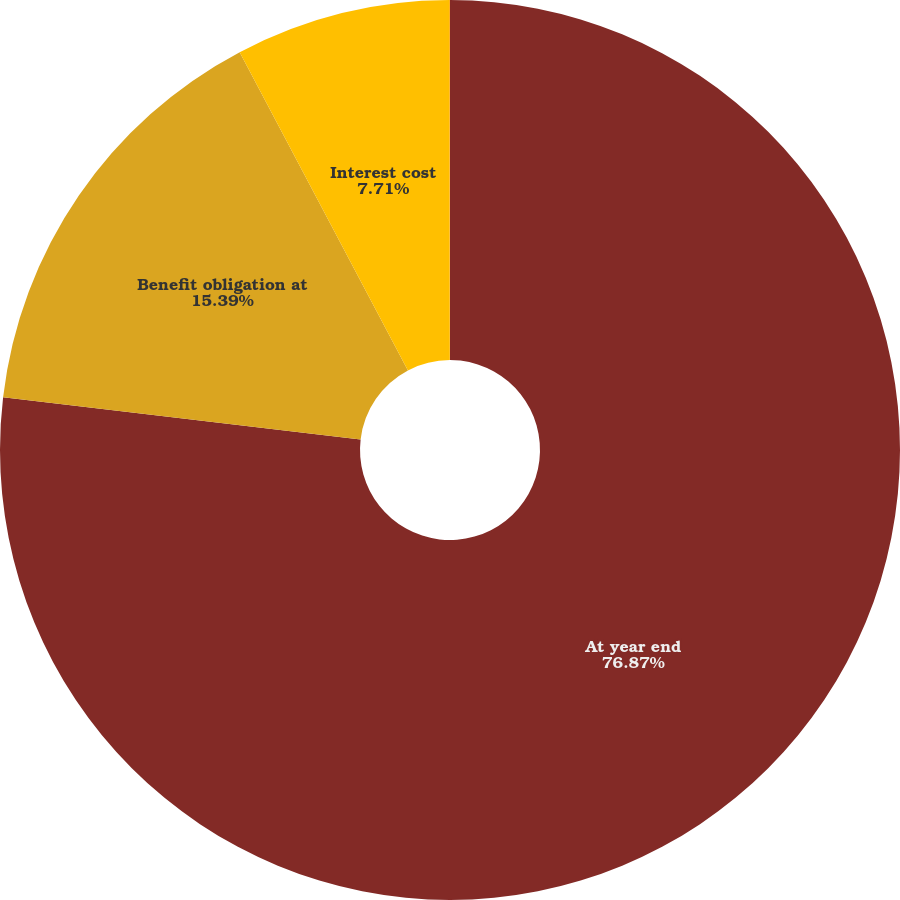Convert chart. <chart><loc_0><loc_0><loc_500><loc_500><pie_chart><fcel>At year end<fcel>Benefit obligation at<fcel>Interest cost<fcel>Actuarial gain<nl><fcel>76.87%<fcel>15.39%<fcel>7.71%<fcel>0.03%<nl></chart> 